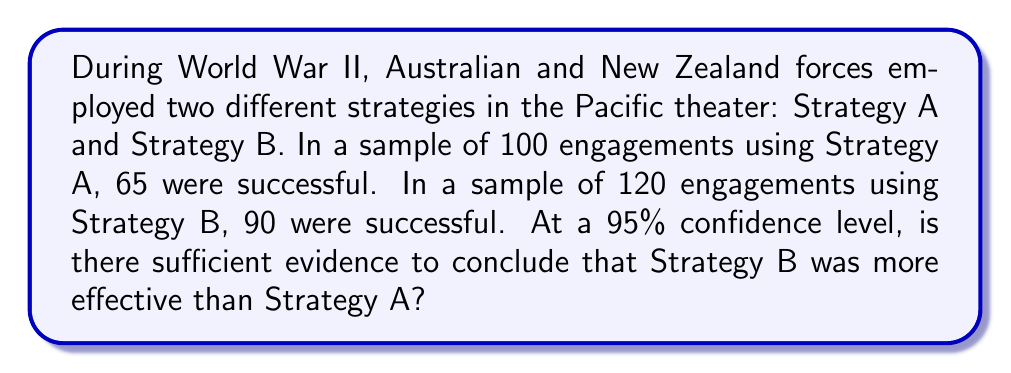Show me your answer to this math problem. To compare the effectiveness of the two strategies, we'll use a hypothesis test for the difference between two population proportions and construct a confidence interval.

Step 1: Define hypotheses
$H_0: p_B - p_A = 0$ (no difference in effectiveness)
$H_a: p_B - p_A > 0$ (Strategy B is more effective)

Step 2: Calculate sample proportions
$\hat{p}_A = \frac{65}{100} = 0.65$
$\hat{p}_B = \frac{90}{120} = 0.75$

Step 3: Calculate pooled proportion
$\hat{p} = \frac{65 + 90}{100 + 120} = \frac{155}{220} \approx 0.7045$

Step 4: Calculate test statistic
$z = \frac{(\hat{p}_B - \hat{p}_A) - 0}{\sqrt{\hat{p}(1-\hat{p})(\frac{1}{n_A} + \frac{1}{n_B})}}$

$z = \frac{0.75 - 0.65}{\sqrt{0.7045(1-0.7045)(\frac{1}{100} + \frac{1}{120})}} \approx 1.6845$

Step 5: Find critical value (one-tailed test, 95% confidence)
$z_{\alpha} = z_{0.05} = 1.645$

Step 6: Compare test statistic to critical value
Since $1.6845 > 1.645$, we reject the null hypothesis.

Step 7: Construct 95% confidence interval for the difference in proportions
$(\hat{p}_B - \hat{p}_A) \pm z_{\alpha/2}\sqrt{\frac{\hat{p}_A(1-\hat{p}_A)}{n_A} + \frac{\hat{p}_B(1-\hat{p}_B)}{n_B}}$

$(0.75 - 0.65) \pm 1.96\sqrt{\frac{0.65(1-0.65)}{100} + \frac{0.75(1-0.75)}{120}}$

$0.10 \pm 1.96(0.0592) = (0.0139, 0.1861)$

The confidence interval does not include 0, supporting the conclusion that Strategy B was more effective.
Answer: Yes, there is sufficient evidence to conclude Strategy B was more effective (p-value < 0.05, 95% CI: (0.0139, 0.1861)). 